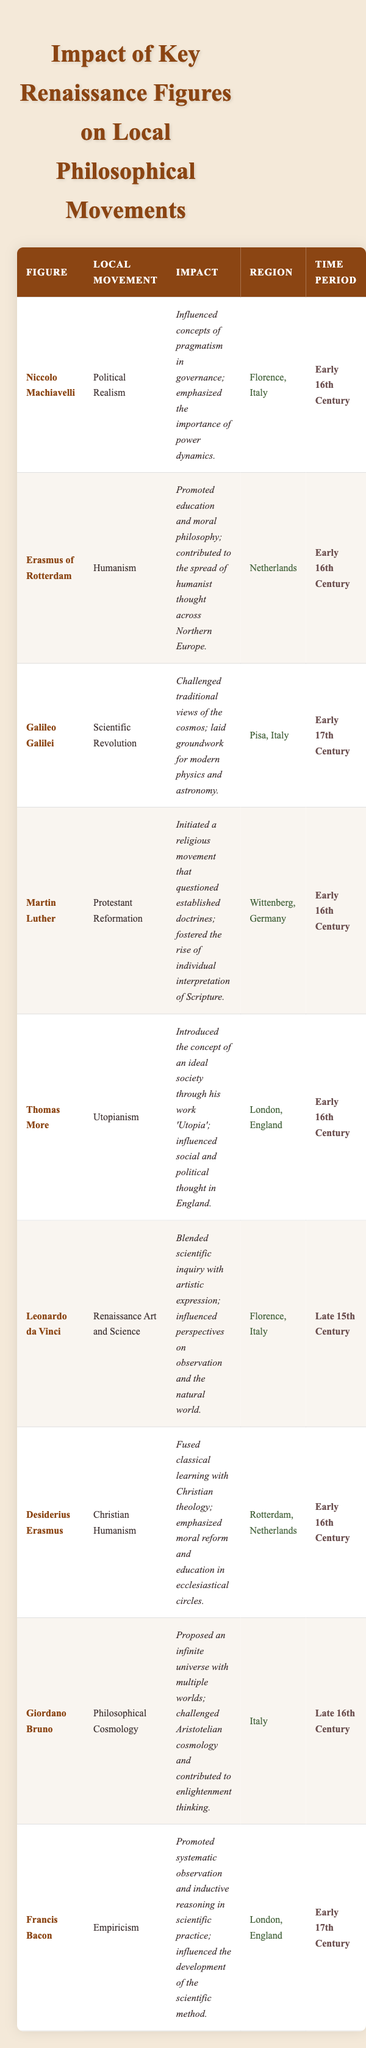What is the local movement associated with Niccolo Machiavelli? The table clearly lists that Niccolo Machiavelli is associated with the local movement "Political Realism."
Answer: Political Realism Which figure contributed to the Scientific Revolution? The table indicates that the figure "Galileo Galilei" contributed to the Scientific Revolution as per the "Local Movement" column.
Answer: Galileo Galilei How many figures are associated with early 16th Century movements? There are six figures listed with impacts in the early 16th Century: Niccolo Machiavelli, Erasmus of Rotterdam, Martin Luther, Thomas More, Desiderius Erasmus, and Leonardo da Vinci.
Answer: 6 Is Francis Bacon associated with the region of Italy? The table states that Francis Bacon is associated with London, England, not Italy. Therefore, the statement is false.
Answer: No What impact did Martin Luther have on local philosophical movements? The table details that Martin Luther initiated a religious movement that questioned established doctrines and fostered individual interpretation of Scripture, which falls under the impact of the Protestant Reformation.
Answer: He fostered individual interpretation of Scripture Which movement was influenced by Leonardo da Vinci? According to the table, Leonardo da Vinci influenced the movement identified as "Renaissance Art and Science."
Answer: Renaissance Art and Science Which movements are associated with England? The table shows two figures linked to movements from England: Thomas More (Utopianism) and Francis Bacon (Empiricism).
Answer: Utopianism and Empiricism Name the figure who introduced the concept of an ideal society. The table indicates that Thomas More introduced the concept of an ideal society through his work 'Utopia.'
Answer: Thomas More What is the main impact of Giordano Bruno’s contributions? The table reveals that Giordano Bruno proposed an infinite universe with multiple worlds and challenged Aristotelian cosmology, influencing Enlightenment thinking as indicated in the "Impact" section.
Answer: Proposed an infinite universe Identify the figure associated with Christian Humanism. The table specifies that Desiderius Erasmus is associated with the local movement of Christian Humanism.
Answer: Desiderius Erasmus How does the impact of Erasmus of Rotterdam differ from that of Machiavelli? Comparing the two, Erasmus of Rotterdam promoted education and moral philosophy in humanism, while Machiavelli influenced pragmatism in governance with his emphasis on power dynamics.
Answer: They focus on humanism vs. pragmatism in governance 